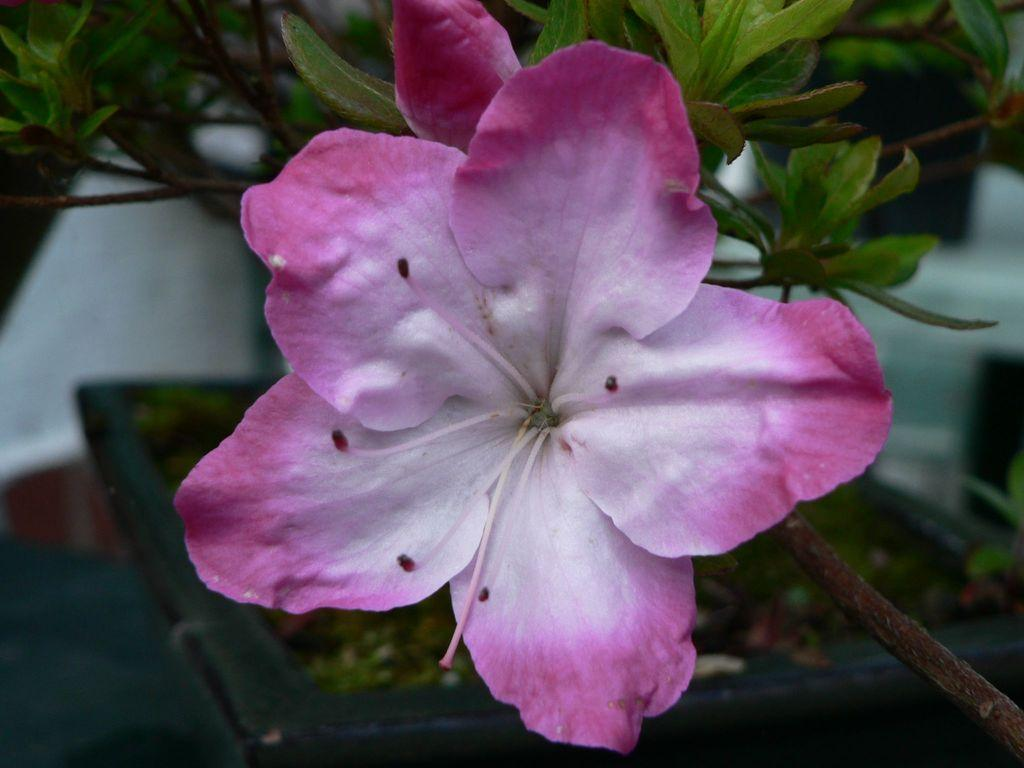What type of plant is visible in the image? There is a flower in the image, which is a type of plant. What is the flower planted in? There is a flower pot at the bottom of the image. Can you describe the plant's surroundings? The image only shows the flower and the flower pot, so there is no additional context provided. How many apples are hanging from the flower in the image? There are no apples present in the image; it features a flower and a flower pot. What type of salt is sprinkled on the plant in the image? There is no salt present in the image; it only features a flower and a flower pot. 